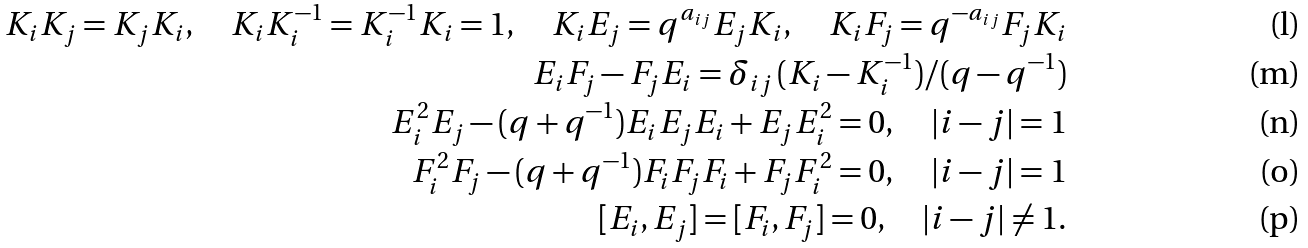<formula> <loc_0><loc_0><loc_500><loc_500>K _ { i } K _ { j } = K _ { j } K _ { i } , \quad K _ { i } K _ { i } ^ { - 1 } = K _ { i } ^ { - 1 } K _ { i } = 1 , \quad K _ { i } E _ { j } = q ^ { a _ { i j } } E _ { j } K _ { i } , \quad K _ { i } F _ { j } = q ^ { - a _ { i j } } F _ { j } K _ { i } \\ E _ { i } F _ { j } - F _ { j } E _ { i } = \delta _ { i j } \, ( K _ { i } - K _ { i } ^ { - 1 } ) / ( q - q ^ { - 1 } ) \\ E _ { i } ^ { 2 } E _ { j } - ( q + q ^ { - 1 } ) E _ { i } E _ { j } E _ { i } + E _ { j } E _ { i } ^ { 2 } = 0 , \quad | i - j | = 1 \\ F _ { i } ^ { 2 } F _ { j } - ( q + q ^ { - 1 } ) F _ { i } F _ { j } F _ { i } + F _ { j } F _ { i } ^ { 2 } = 0 , \quad | i - j | = 1 \\ [ E _ { i } , E _ { j } ] = [ F _ { i } , F _ { j } ] = 0 , \quad | i - j | \ne 1 .</formula> 